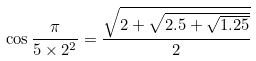<formula> <loc_0><loc_0><loc_500><loc_500>\cos { \frac { \pi } { 5 \times 2 ^ { 2 } } } = { \frac { \sqrt { 2 + { \sqrt { 2 . 5 + { \sqrt { 1 . 2 5 } } } } } } { 2 } }</formula> 